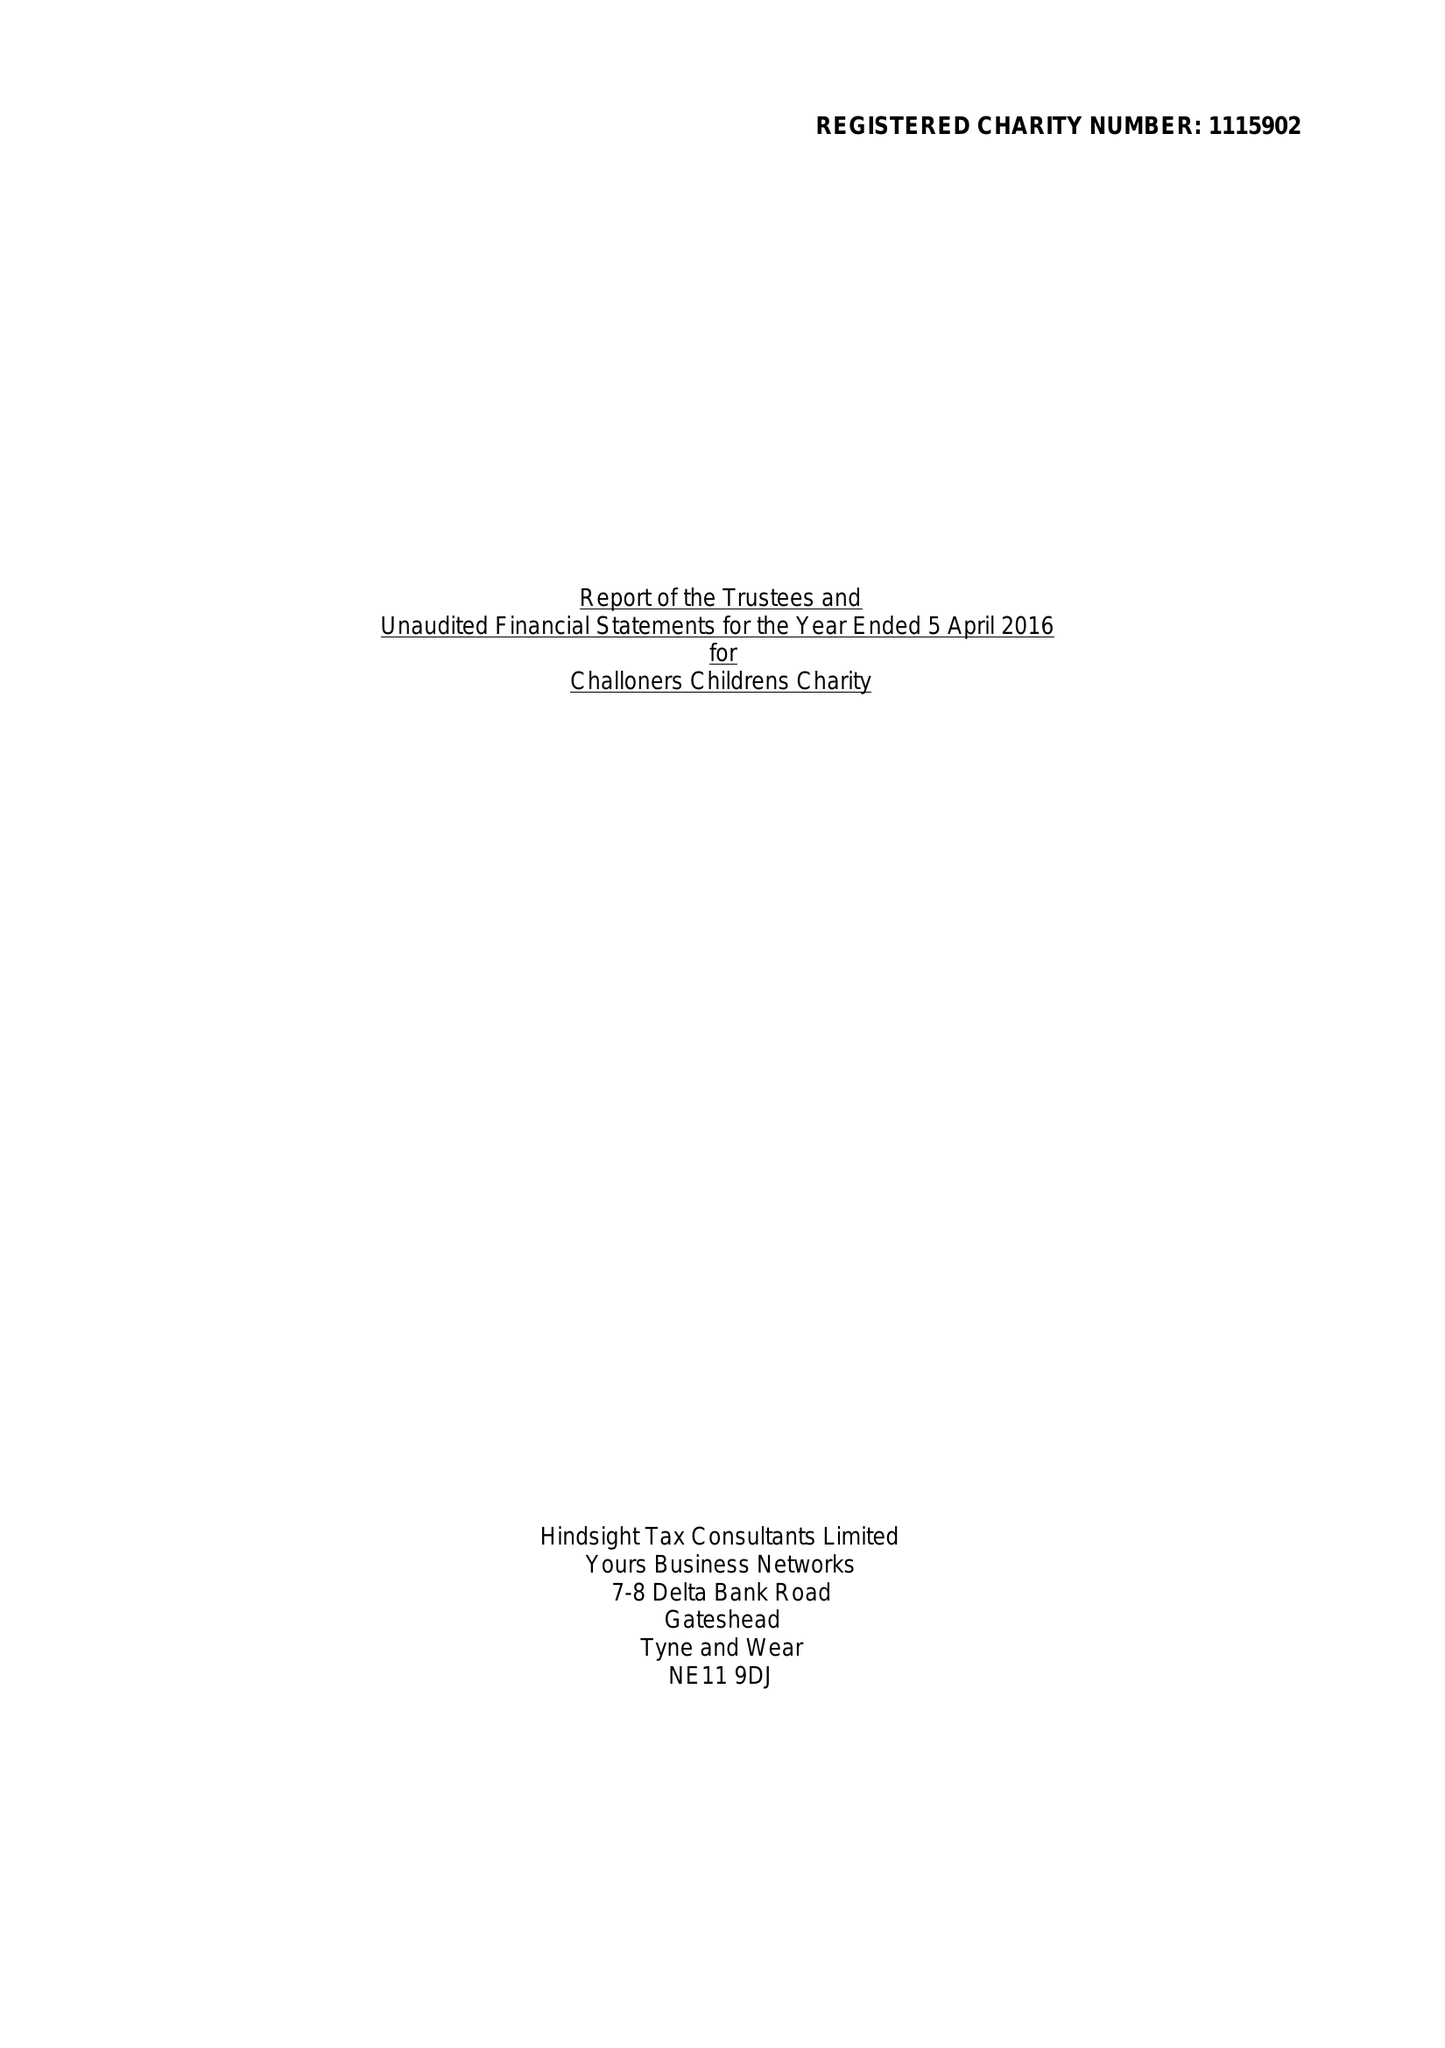What is the value for the address__post_town?
Answer the question using a single word or phrase. LONDON 